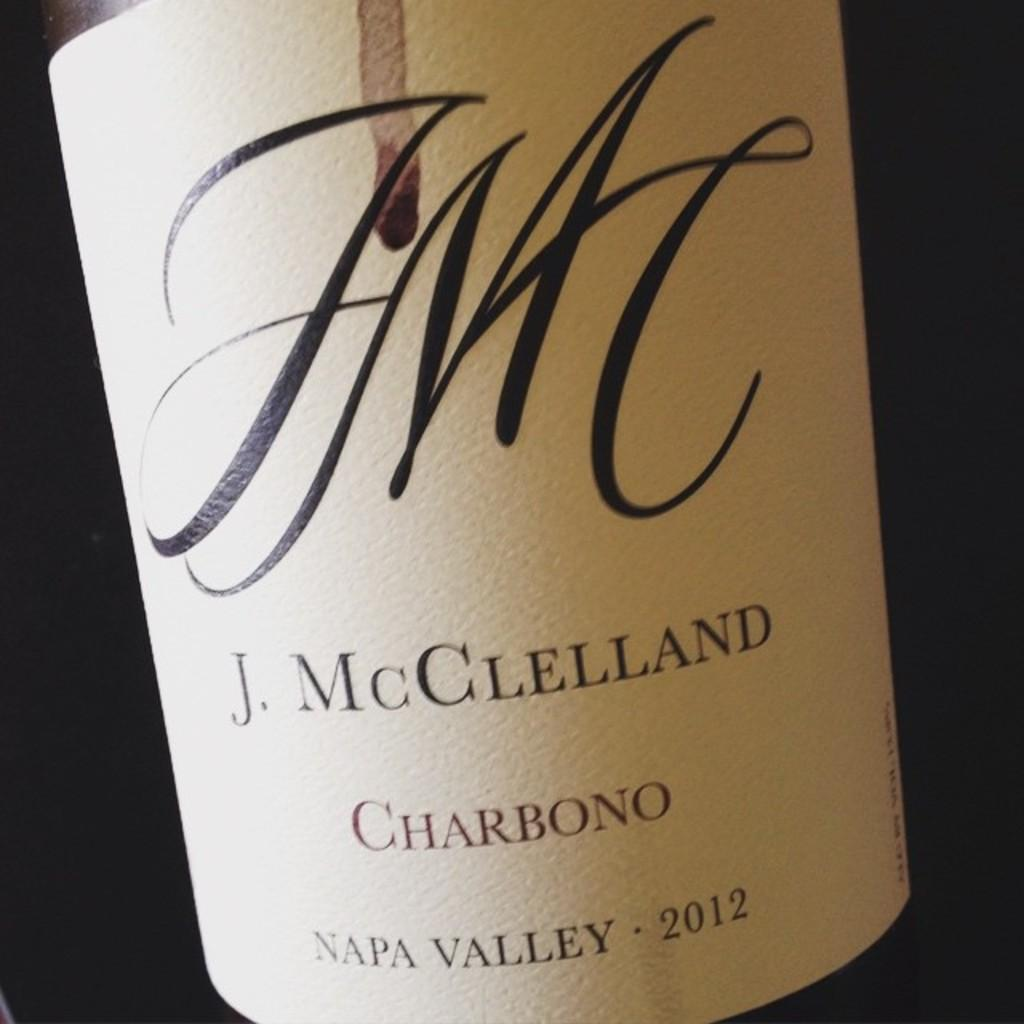<image>
Share a concise interpretation of the image provided. Label of a wine which has the year 2012. 